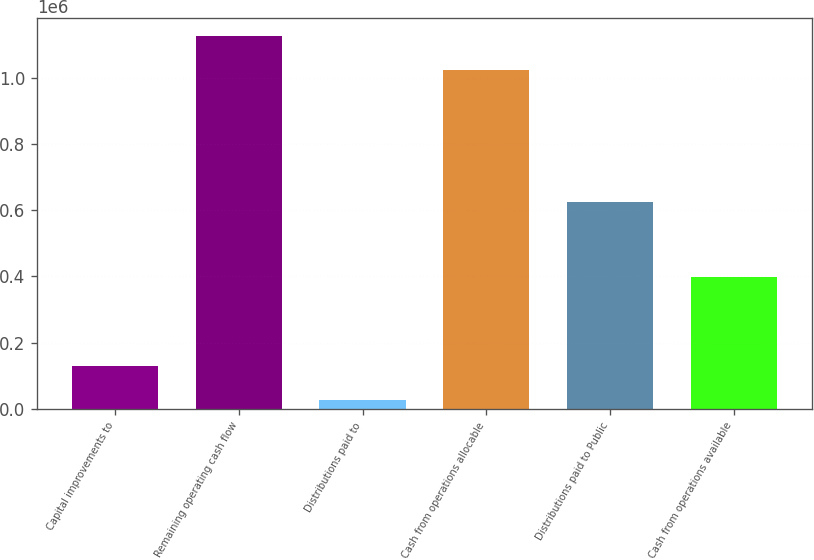Convert chart. <chart><loc_0><loc_0><loc_500><loc_500><bar_chart><fcel>Capital improvements to<fcel>Remaining operating cash flow<fcel>Distributions paid to<fcel>Cash from operations allocable<fcel>Distributions paid to Public<fcel>Cash from operations available<nl><fcel>130491<fcel>1.12446e+06<fcel>28267<fcel>1.02224e+06<fcel>624665<fcel>397573<nl></chart> 